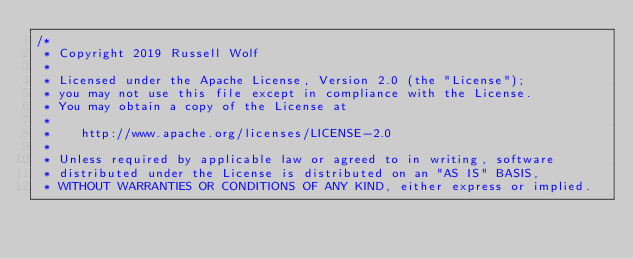<code> <loc_0><loc_0><loc_500><loc_500><_Kotlin_>/*
 * Copyright 2019 Russell Wolf
 *
 * Licensed under the Apache License, Version 2.0 (the "License");
 * you may not use this file except in compliance with the License.
 * You may obtain a copy of the License at
 *
 *    http://www.apache.org/licenses/LICENSE-2.0
 *
 * Unless required by applicable law or agreed to in writing, software
 * distributed under the License is distributed on an "AS IS" BASIS,
 * WITHOUT WARRANTIES OR CONDITIONS OF ANY KIND, either express or implied.</code> 